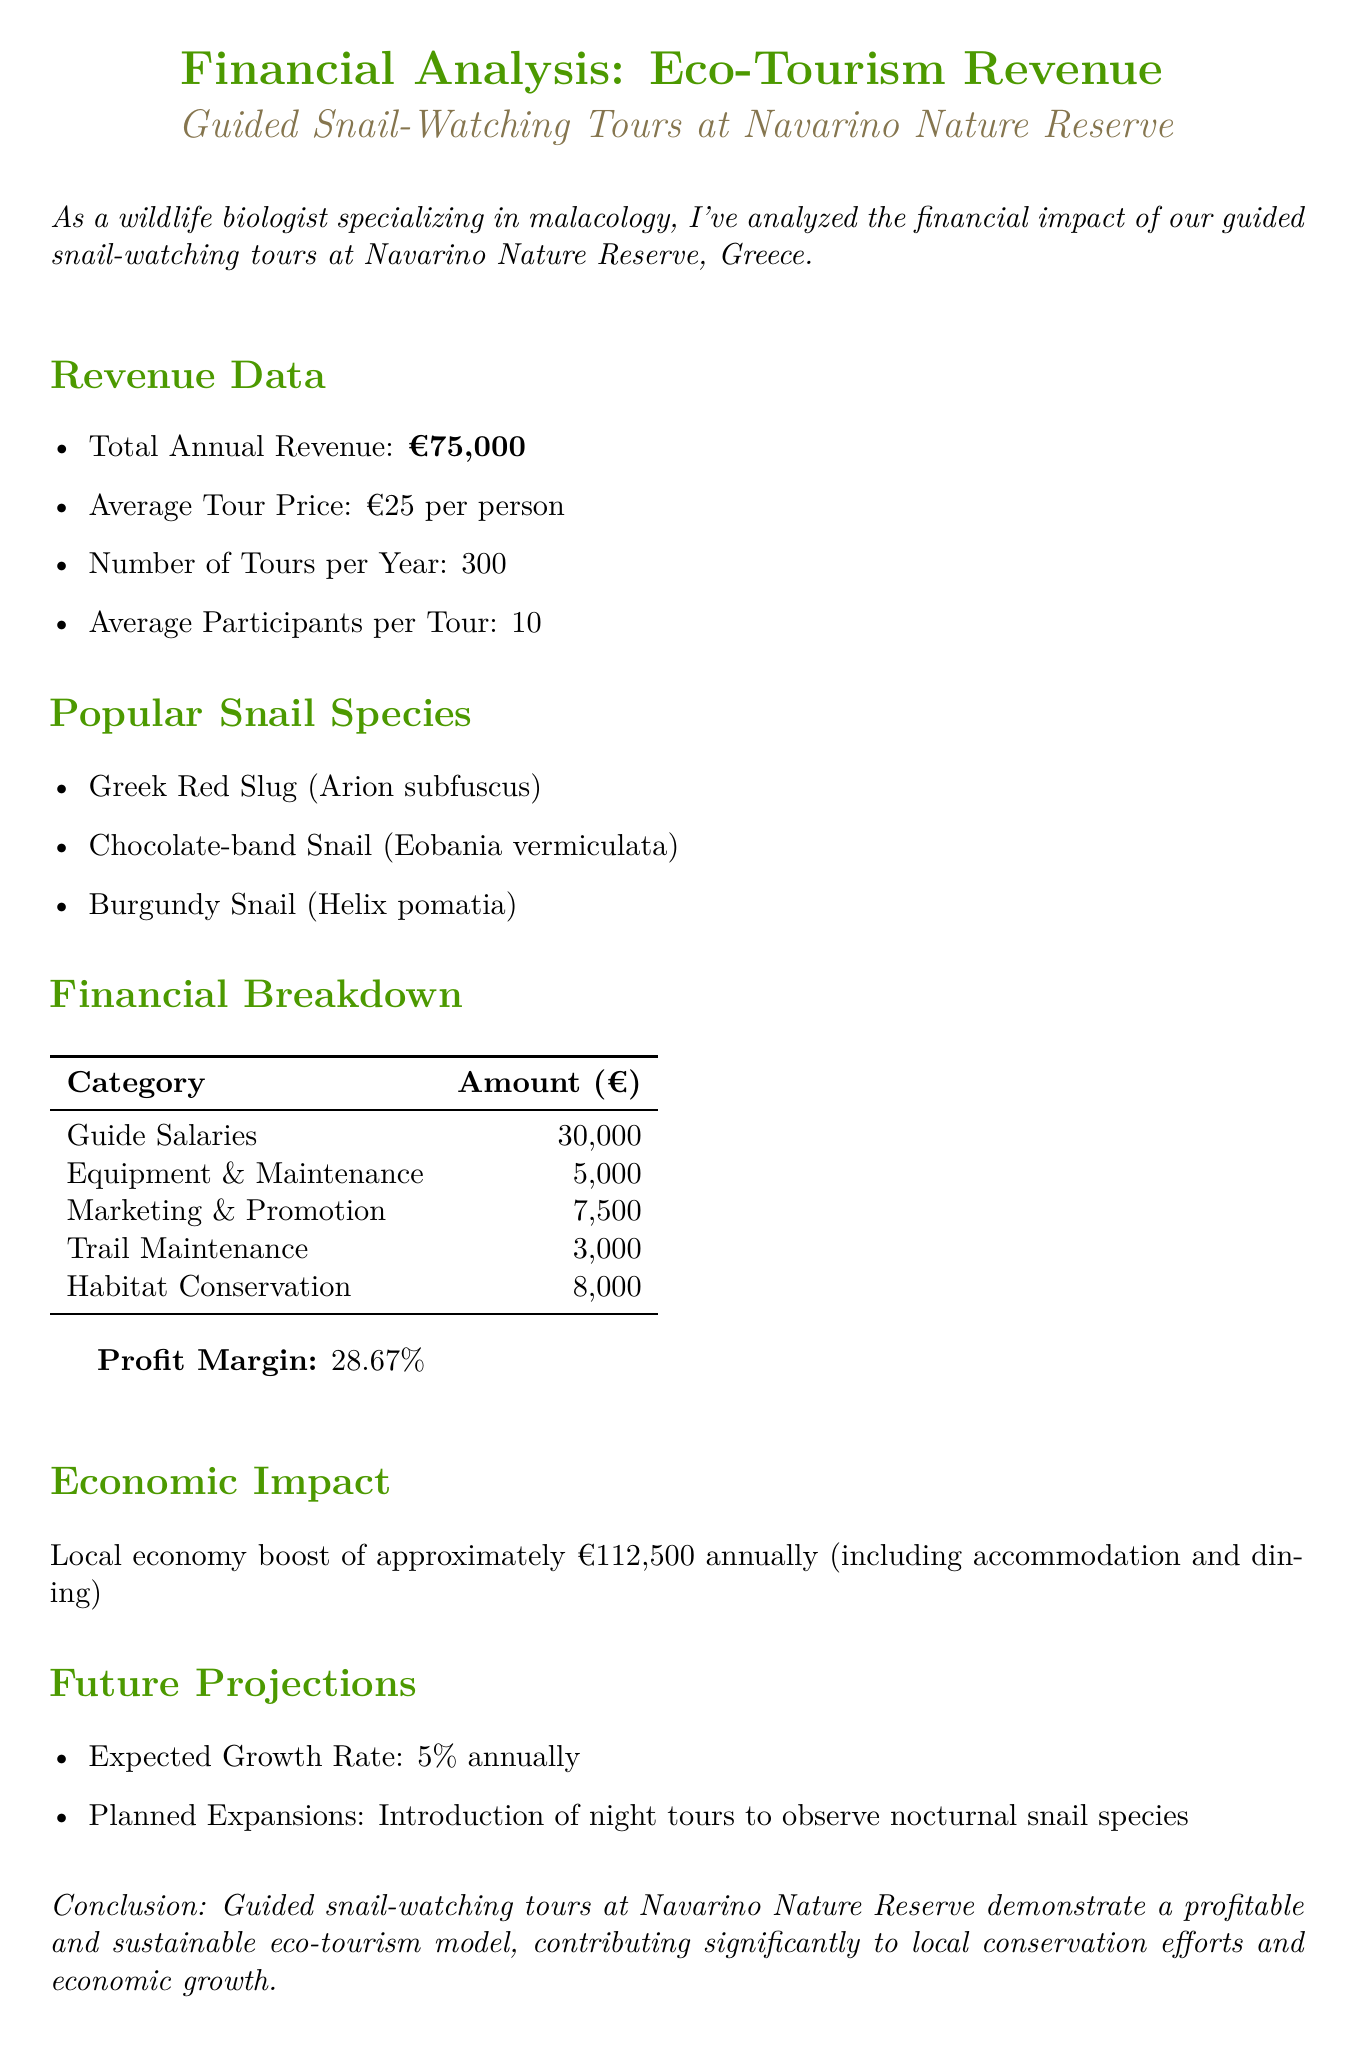what is the total annual revenue? The total annual revenue is explicitly stated in the revenue data section of the document.
Answer: €75,000 what is the average tour price per person? The average tour price is given in the revenue data section, showing the price for each participant.
Answer: €25 per person how many tours are conducted per year? The number of tours per year is provided in the revenue data section, indicating the total tours scheduled.
Answer: 300 what is the profit margin percentage? The profit margin is calculated and presented in a dedicated section related to financial performance.
Answer: 28.67% what is the expected annual growth rate? The expected growth rate is mentioned in the future projections section, indicating forecasted revenue increase.
Answer: 5% annually how much is allocated for habitat conservation? The amount for habitat conservation is specifically listed under operational costs as part of sustainability measures.
Answer: €8,000 which snail species is mentioned first in the popular species list? The first species listed in the popular snail species section of the document can be directly referenced.
Answer: Greek Red Slug (Arion subfuscus) what is the total economic impact on the local economy? The economic impact is quantified and reported in the corresponding section, summarizing the financial benefit.
Answer: approximately €112,500 annually what are the planned expansions for the future? Planned expansions are detailed in the future projections section, showing the intention for growth.
Answer: Introduction of night tours to observe nocturnal snail species 